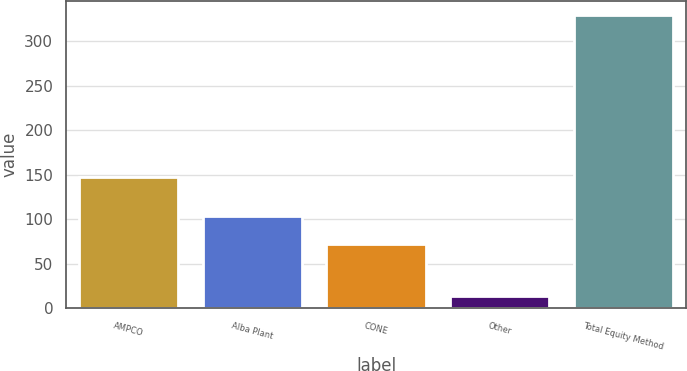Convert chart. <chart><loc_0><loc_0><loc_500><loc_500><bar_chart><fcel>AMPCO<fcel>Alba Plant<fcel>CONE<fcel>Other<fcel>Total Equity Method<nl><fcel>147<fcel>103.5<fcel>72<fcel>14<fcel>329<nl></chart> 